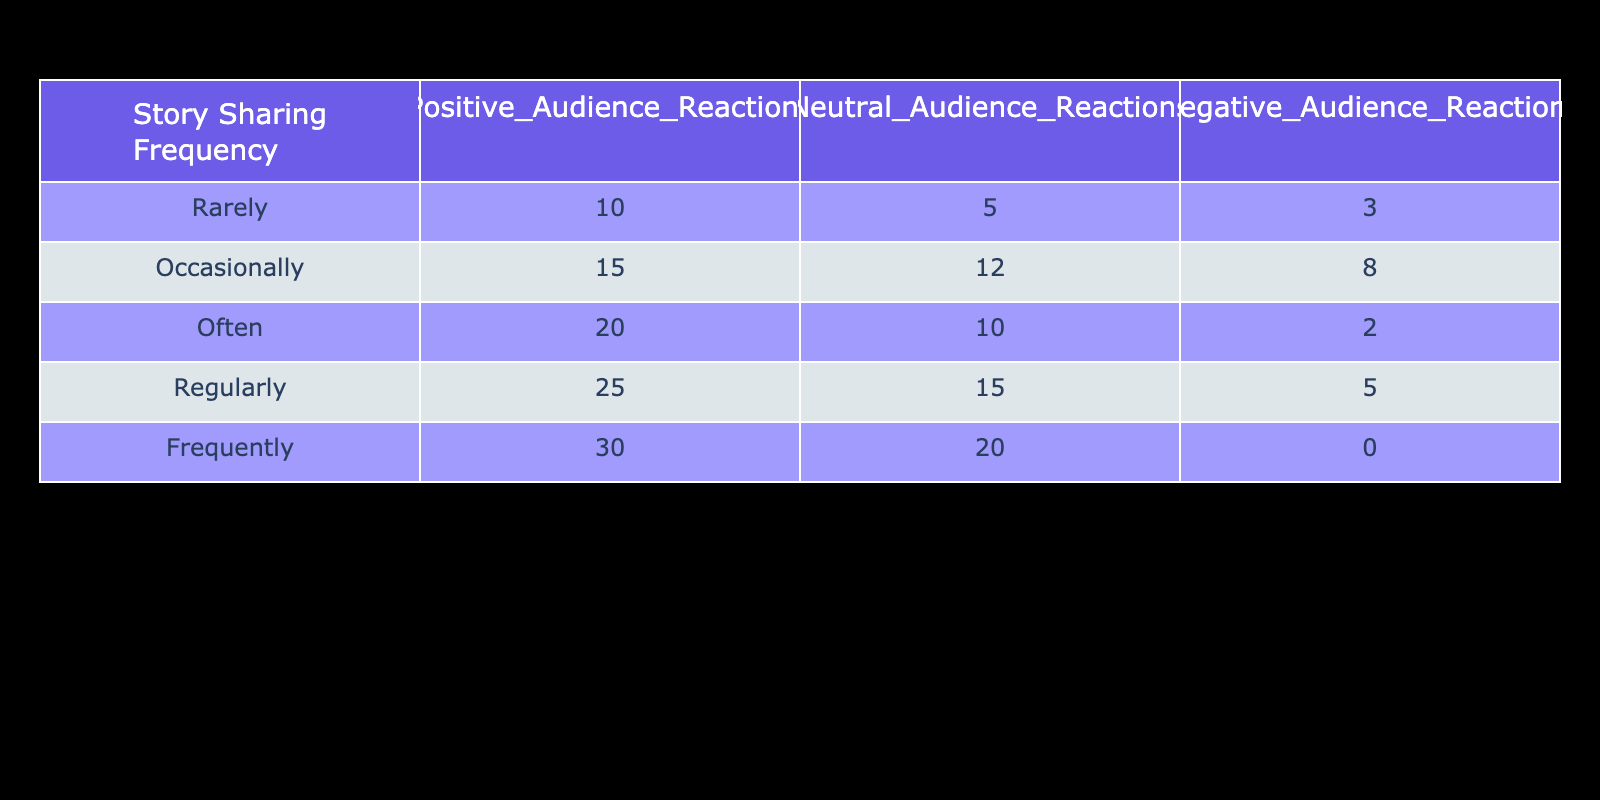What is the total number of positive audience reactions across all sharing frequencies? To get the total number of positive reactions, we add the values in the "Positive Audience Reactions" column: 10 + 15 + 20 + 25 + 30 = 100.
Answer: 100 How many stories were shared regularly with negative audience reactions? The number of stories shared regularly with negative reactions is directly retrieved from the table; under "Regularly," the value for "Negative Audience Reactions" is 5.
Answer: 5 What is the average number of neutral audience reactions for each frequency of story sharing? To find the average, we add the neutral reactions: 5 + 12 + 10 + 15 + 20 = 72. There are 5 frequencies, so we divide: 72/5 = 14.4.
Answer: 14.4 Is it true that frequently shared stories received no negative audience reactions? Looking at the "Frequently" row under "Negative Audience Reactions," the value is 0, which confirms the statement is true.
Answer: Yes What is the difference in the number of positive audience reactions between those who share often and those who share occasionally? To find the difference, we take the number of positive reactions for "Often," which is 20, and subtract the number of reactions for "Occasionally," which is 15; thus, 20 - 15 = 5.
Answer: 5 How many total negative audience reactions were there for all story sharing frequencies? The total number of negative reactions is calculated by summing the values in the "Negative Audience Reactions" column: 3 + 8 + 2 + 5 + 0 = 18.
Answer: 18 What percentage of stories that were shared frequently received positive audience reactions? The value for "Frequently" in positive reactions is 30. The total reactions for frequently shared stories are the sum of all reactions: 30 + 20 + 0 = 50. The percentage is calculated as (30/50) * 100% = 60%.
Answer: 60% What is the highest number of neutral audience reactions recorded in the table, and at which frequency? The highest value in the "Neutral Audience Reactions" column is 20, found in the "Frequently" frequency. The value is confirmed by direct observation of that row.
Answer: 20, Frequently What trend can we observe between story sharing frequency and negative audience reactions? By examining the table, we can see that as the frequency of story sharing increases, the number of negative audience reactions decreases. This indicates an inverse relationship.
Answer: Inverse relationship 